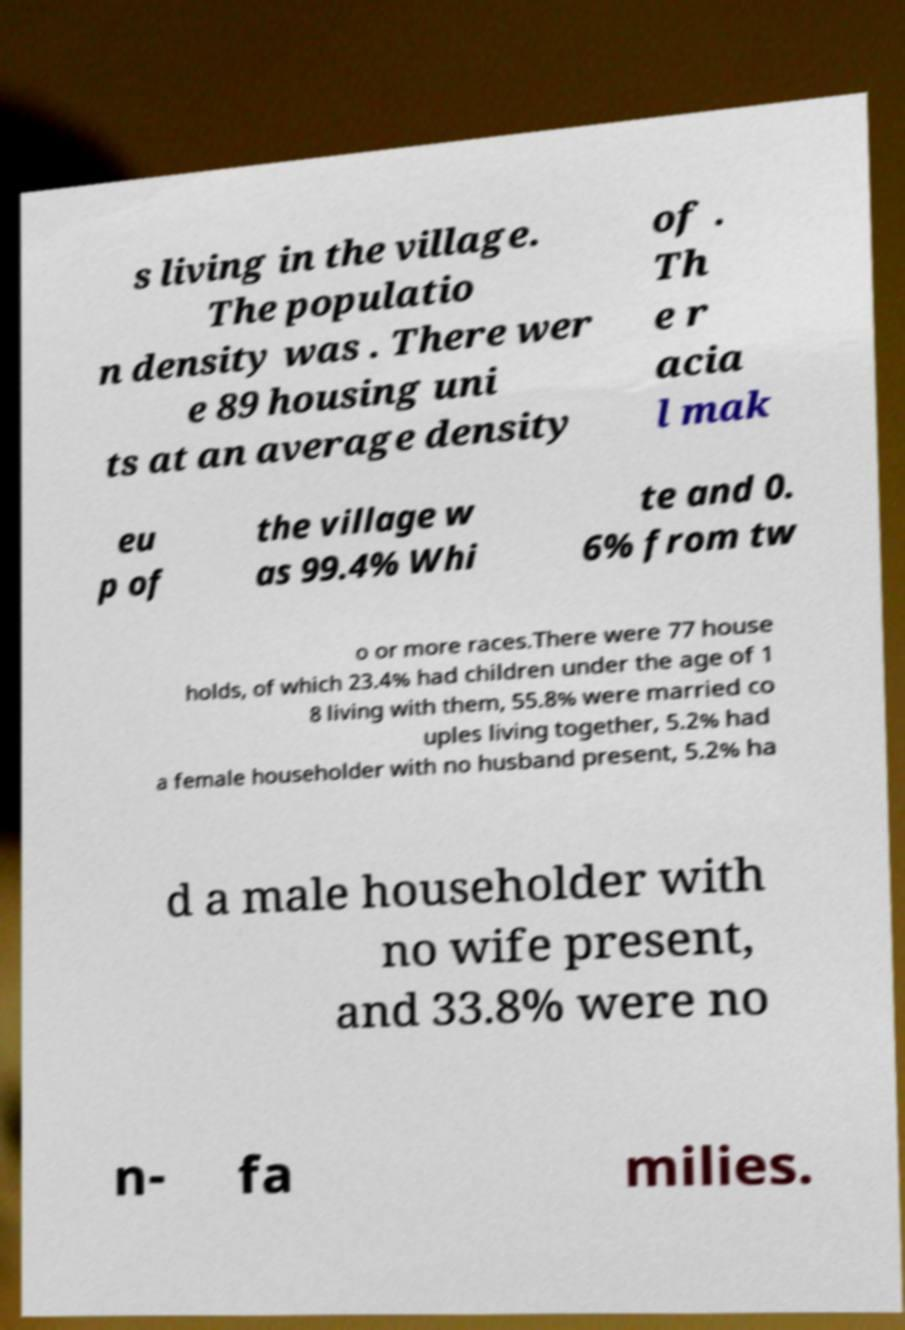Can you accurately transcribe the text from the provided image for me? s living in the village. The populatio n density was . There wer e 89 housing uni ts at an average density of . Th e r acia l mak eu p of the village w as 99.4% Whi te and 0. 6% from tw o or more races.There were 77 house holds, of which 23.4% had children under the age of 1 8 living with them, 55.8% were married co uples living together, 5.2% had a female householder with no husband present, 5.2% ha d a male householder with no wife present, and 33.8% were no n- fa milies. 